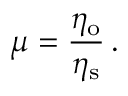Convert formula to latex. <formula><loc_0><loc_0><loc_500><loc_500>\mu = \frac { \eta _ { o } } { \eta _ { s } } \, .</formula> 